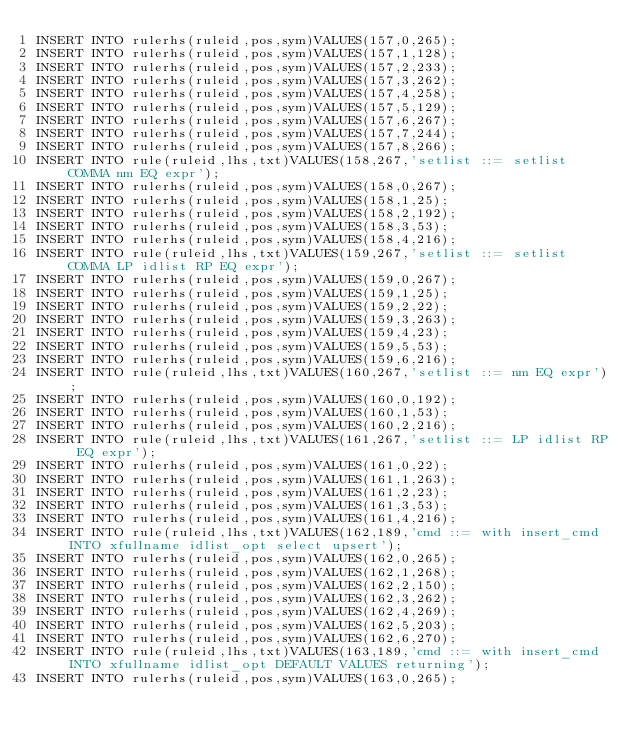<code> <loc_0><loc_0><loc_500><loc_500><_SQL_>INSERT INTO rulerhs(ruleid,pos,sym)VALUES(157,0,265);
INSERT INTO rulerhs(ruleid,pos,sym)VALUES(157,1,128);
INSERT INTO rulerhs(ruleid,pos,sym)VALUES(157,2,233);
INSERT INTO rulerhs(ruleid,pos,sym)VALUES(157,3,262);
INSERT INTO rulerhs(ruleid,pos,sym)VALUES(157,4,258);
INSERT INTO rulerhs(ruleid,pos,sym)VALUES(157,5,129);
INSERT INTO rulerhs(ruleid,pos,sym)VALUES(157,6,267);
INSERT INTO rulerhs(ruleid,pos,sym)VALUES(157,7,244);
INSERT INTO rulerhs(ruleid,pos,sym)VALUES(157,8,266);
INSERT INTO rule(ruleid,lhs,txt)VALUES(158,267,'setlist ::= setlist COMMA nm EQ expr');
INSERT INTO rulerhs(ruleid,pos,sym)VALUES(158,0,267);
INSERT INTO rulerhs(ruleid,pos,sym)VALUES(158,1,25);
INSERT INTO rulerhs(ruleid,pos,sym)VALUES(158,2,192);
INSERT INTO rulerhs(ruleid,pos,sym)VALUES(158,3,53);
INSERT INTO rulerhs(ruleid,pos,sym)VALUES(158,4,216);
INSERT INTO rule(ruleid,lhs,txt)VALUES(159,267,'setlist ::= setlist COMMA LP idlist RP EQ expr');
INSERT INTO rulerhs(ruleid,pos,sym)VALUES(159,0,267);
INSERT INTO rulerhs(ruleid,pos,sym)VALUES(159,1,25);
INSERT INTO rulerhs(ruleid,pos,sym)VALUES(159,2,22);
INSERT INTO rulerhs(ruleid,pos,sym)VALUES(159,3,263);
INSERT INTO rulerhs(ruleid,pos,sym)VALUES(159,4,23);
INSERT INTO rulerhs(ruleid,pos,sym)VALUES(159,5,53);
INSERT INTO rulerhs(ruleid,pos,sym)VALUES(159,6,216);
INSERT INTO rule(ruleid,lhs,txt)VALUES(160,267,'setlist ::= nm EQ expr');
INSERT INTO rulerhs(ruleid,pos,sym)VALUES(160,0,192);
INSERT INTO rulerhs(ruleid,pos,sym)VALUES(160,1,53);
INSERT INTO rulerhs(ruleid,pos,sym)VALUES(160,2,216);
INSERT INTO rule(ruleid,lhs,txt)VALUES(161,267,'setlist ::= LP idlist RP EQ expr');
INSERT INTO rulerhs(ruleid,pos,sym)VALUES(161,0,22);
INSERT INTO rulerhs(ruleid,pos,sym)VALUES(161,1,263);
INSERT INTO rulerhs(ruleid,pos,sym)VALUES(161,2,23);
INSERT INTO rulerhs(ruleid,pos,sym)VALUES(161,3,53);
INSERT INTO rulerhs(ruleid,pos,sym)VALUES(161,4,216);
INSERT INTO rule(ruleid,lhs,txt)VALUES(162,189,'cmd ::= with insert_cmd INTO xfullname idlist_opt select upsert');
INSERT INTO rulerhs(ruleid,pos,sym)VALUES(162,0,265);
INSERT INTO rulerhs(ruleid,pos,sym)VALUES(162,1,268);
INSERT INTO rulerhs(ruleid,pos,sym)VALUES(162,2,150);
INSERT INTO rulerhs(ruleid,pos,sym)VALUES(162,3,262);
INSERT INTO rulerhs(ruleid,pos,sym)VALUES(162,4,269);
INSERT INTO rulerhs(ruleid,pos,sym)VALUES(162,5,203);
INSERT INTO rulerhs(ruleid,pos,sym)VALUES(162,6,270);
INSERT INTO rule(ruleid,lhs,txt)VALUES(163,189,'cmd ::= with insert_cmd INTO xfullname idlist_opt DEFAULT VALUES returning');
INSERT INTO rulerhs(ruleid,pos,sym)VALUES(163,0,265);</code> 